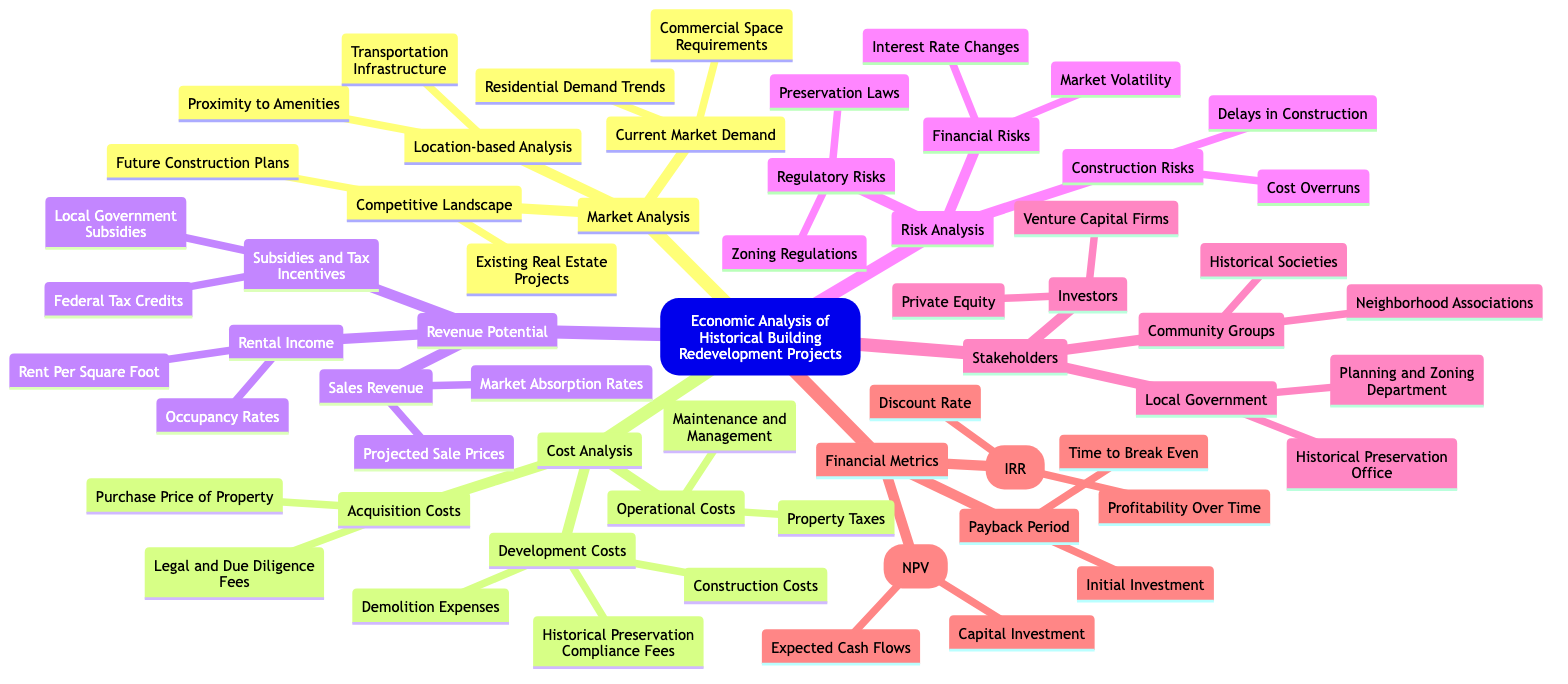What are the main components of Cost Analysis? The Cost Analysis section has three components: Acquisition Costs, Development Costs, and Operational Costs, as clearly indicated in the diagram under that node.
Answer: Acquisition Costs, Development Costs, Operational Costs Which revenue potential category includes 'Projected Sale Prices'? 'Projected Sale Prices' is listed under the Sales Revenue category, which is a part of the Revenue Potential section from the diagram.
Answer: Sales Revenue How many types of risks are categorized under Risk Analysis? The Risk Analysis section is divided into three types: Financial Risks, Regulatory Risks, and Construction Risks, totaling three types based on the visual grouping in the diagram.
Answer: 3 What is the focus of the Market Analysis section? The Market Analysis section focuses on three main areas: Current Market Demand, Competitive Landscape, and Location-based Analysis, as seen in the diagram.
Answer: Current Market Demand, Competitive Landscape, Location-based Analysis How many stakeholders are identified within the Stakeholders section? The Stakeholders section identifies three categories of stakeholders: Investors, Local Government, and Community Groups, summing up to three distinct groups.
Answer: 3 What type of risks does 'Zoning Regulations' represent? 'Zoning Regulations' falls under Regulatory Risks, which is one of the risk categories defined in the Risk Analysis section of the diagram.
Answer: Regulatory Risks What is included under Operational Costs in the Cost Analysis? The Operational Costs subsection includes Maintenance and Management as well as Property Taxes, both of which are specified under this category in the diagram.
Answer: Maintenance and Management, Property Taxes Which financial metric would you consider for determining the time to break even? The Payback Period metric is specifically focused on understanding the time to break even according to its description in the Financial Metrics section of the diagram.
Answer: Payback Period How many different types of Revenue Potential are there in the diagram? The Revenue Potential section is divided into three distinct categories: Sales Revenue, Rental Income, and Subsidies and Tax Incentives, totaling three types of revenue potential.
Answer: 3 